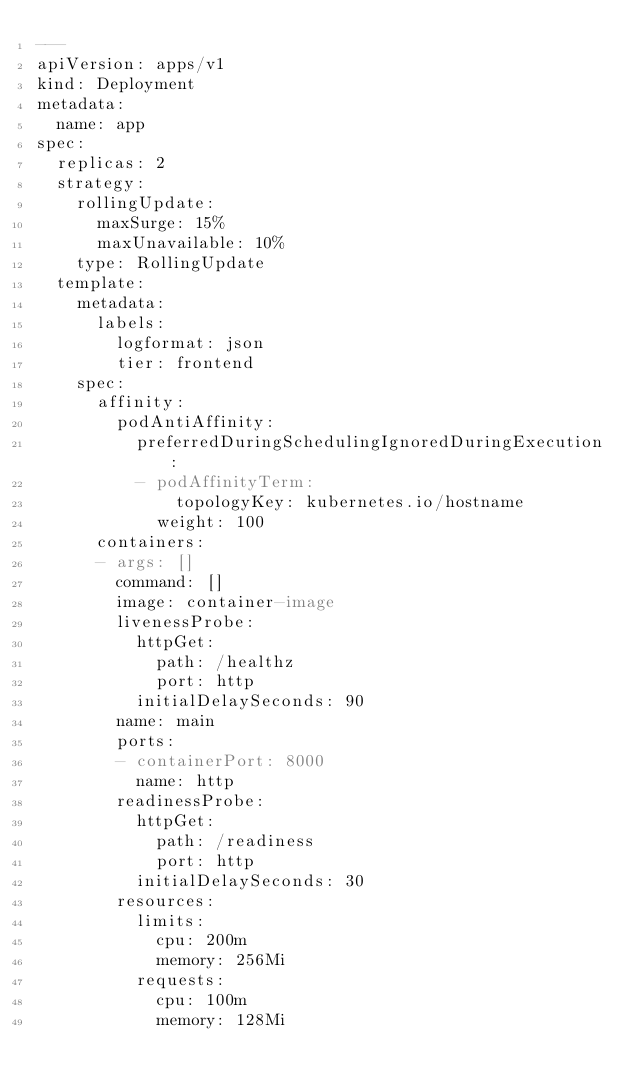Convert code to text. <code><loc_0><loc_0><loc_500><loc_500><_YAML_>---
apiVersion: apps/v1
kind: Deployment
metadata:
  name: app
spec:
  replicas: 2
  strategy:
    rollingUpdate:
      maxSurge: 15%
      maxUnavailable: 10%
    type: RollingUpdate
  template:
    metadata:
      labels:
        logformat: json
        tier: frontend
    spec:
      affinity:
        podAntiAffinity:
          preferredDuringSchedulingIgnoredDuringExecution:
          - podAffinityTerm:
              topologyKey: kubernetes.io/hostname
            weight: 100
      containers:
      - args: []
        command: []
        image: container-image
        livenessProbe:
          httpGet:
            path: /healthz
            port: http
          initialDelaySeconds: 90
        name: main
        ports:
        - containerPort: 8000
          name: http
        readinessProbe:
          httpGet:
            path: /readiness
            port: http
          initialDelaySeconds: 30
        resources:
          limits:
            cpu: 200m
            memory: 256Mi
          requests:
            cpu: 100m
            memory: 128Mi
</code> 